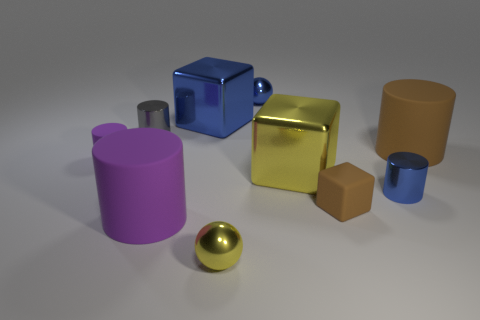Subtract all large purple rubber cylinders. How many cylinders are left? 4 Subtract all tiny metallic things. Subtract all blue cylinders. How many objects are left? 5 Add 5 big purple cylinders. How many big purple cylinders are left? 6 Add 10 green matte cylinders. How many green matte cylinders exist? 10 Subtract all blue cylinders. How many cylinders are left? 4 Subtract 0 green spheres. How many objects are left? 10 Subtract all balls. How many objects are left? 8 Subtract 1 balls. How many balls are left? 1 Subtract all brown cylinders. Subtract all purple blocks. How many cylinders are left? 4 Subtract all blue spheres. How many yellow cubes are left? 1 